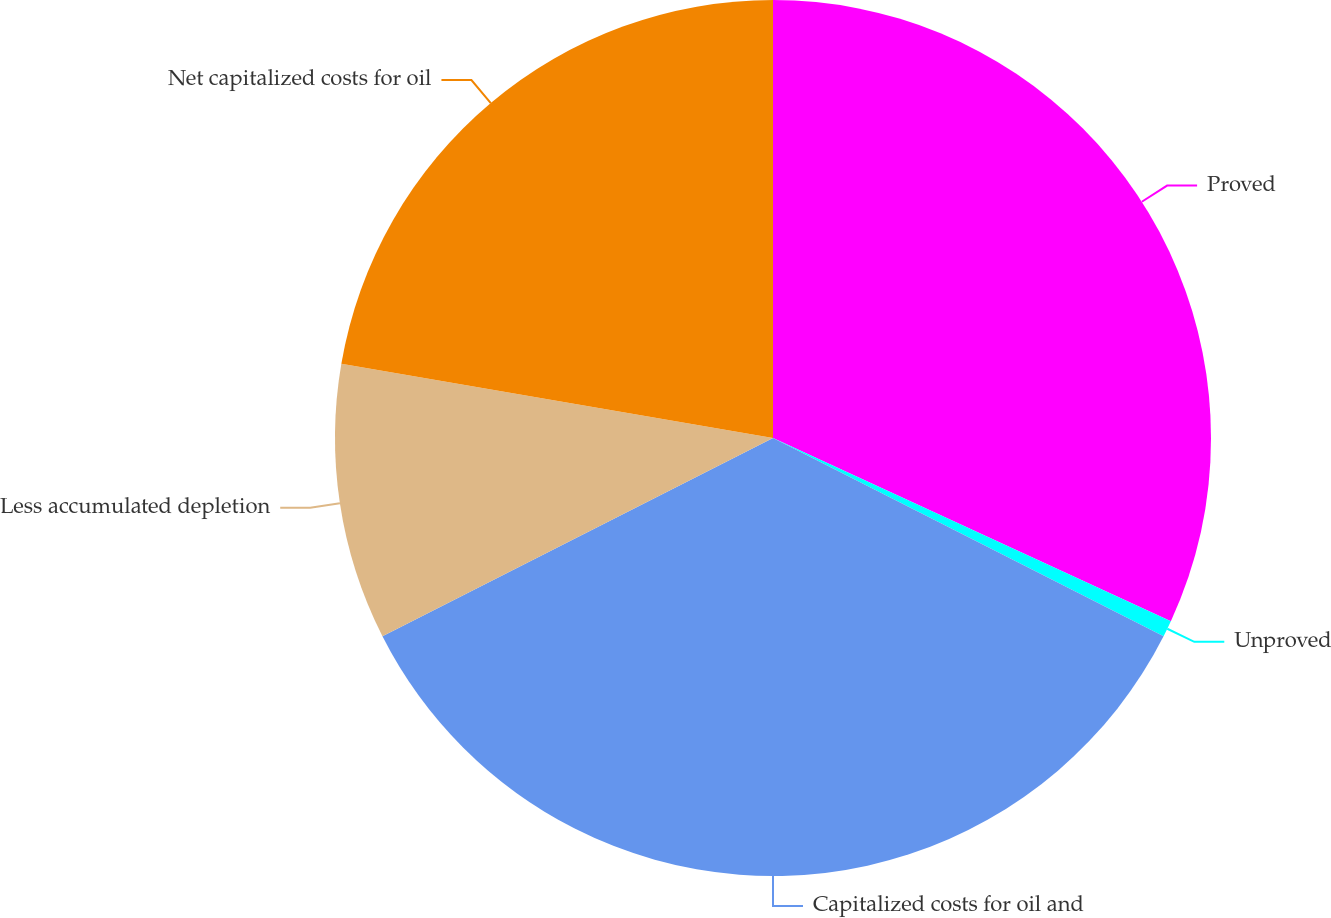Convert chart to OTSL. <chart><loc_0><loc_0><loc_500><loc_500><pie_chart><fcel>Proved<fcel>Unproved<fcel>Capitalized costs for oil and<fcel>Less accumulated depletion<fcel>Net capitalized costs for oil<nl><fcel>31.87%<fcel>0.61%<fcel>35.05%<fcel>10.19%<fcel>22.29%<nl></chart> 